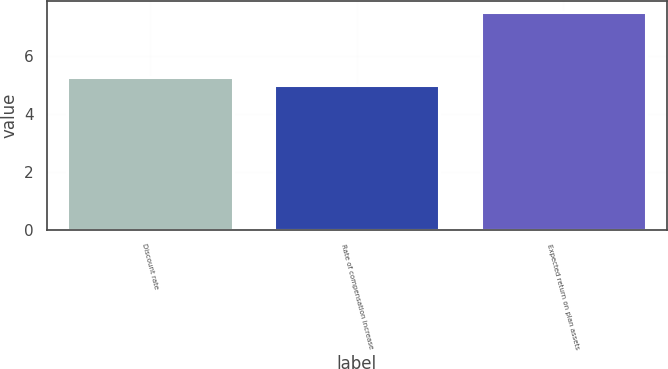Convert chart to OTSL. <chart><loc_0><loc_0><loc_500><loc_500><bar_chart><fcel>Discount rate<fcel>Rate of compensation increase<fcel>Expected return on plan assets<nl><fcel>5.25<fcel>5<fcel>7.5<nl></chart> 